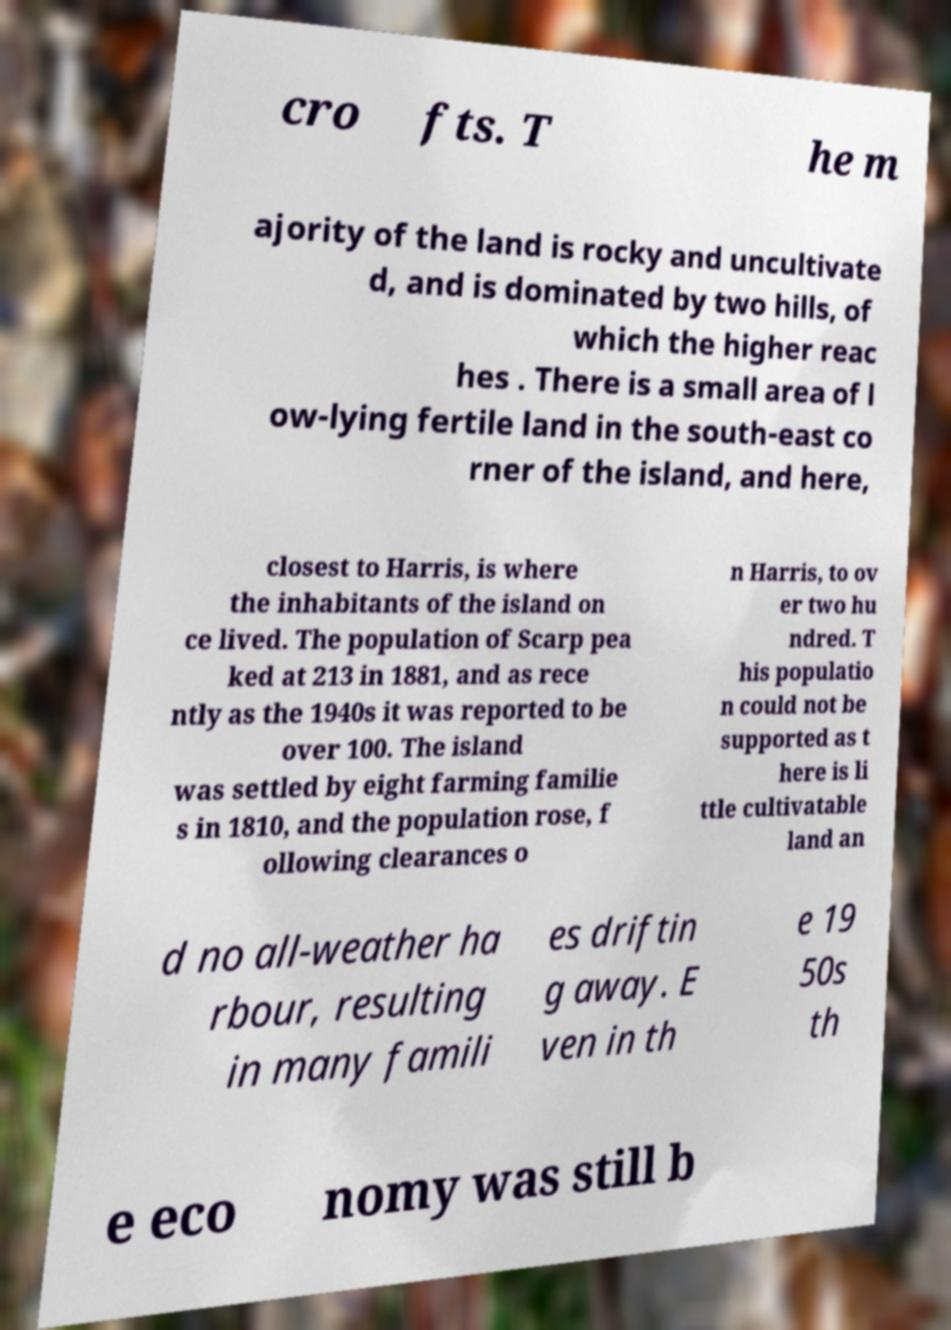What messages or text are displayed in this image? I need them in a readable, typed format. cro fts. T he m ajority of the land is rocky and uncultivate d, and is dominated by two hills, of which the higher reac hes . There is a small area of l ow-lying fertile land in the south-east co rner of the island, and here, closest to Harris, is where the inhabitants of the island on ce lived. The population of Scarp pea ked at 213 in 1881, and as rece ntly as the 1940s it was reported to be over 100. The island was settled by eight farming familie s in 1810, and the population rose, f ollowing clearances o n Harris, to ov er two hu ndred. T his populatio n could not be supported as t here is li ttle cultivatable land an d no all-weather ha rbour, resulting in many famili es driftin g away. E ven in th e 19 50s th e eco nomy was still b 